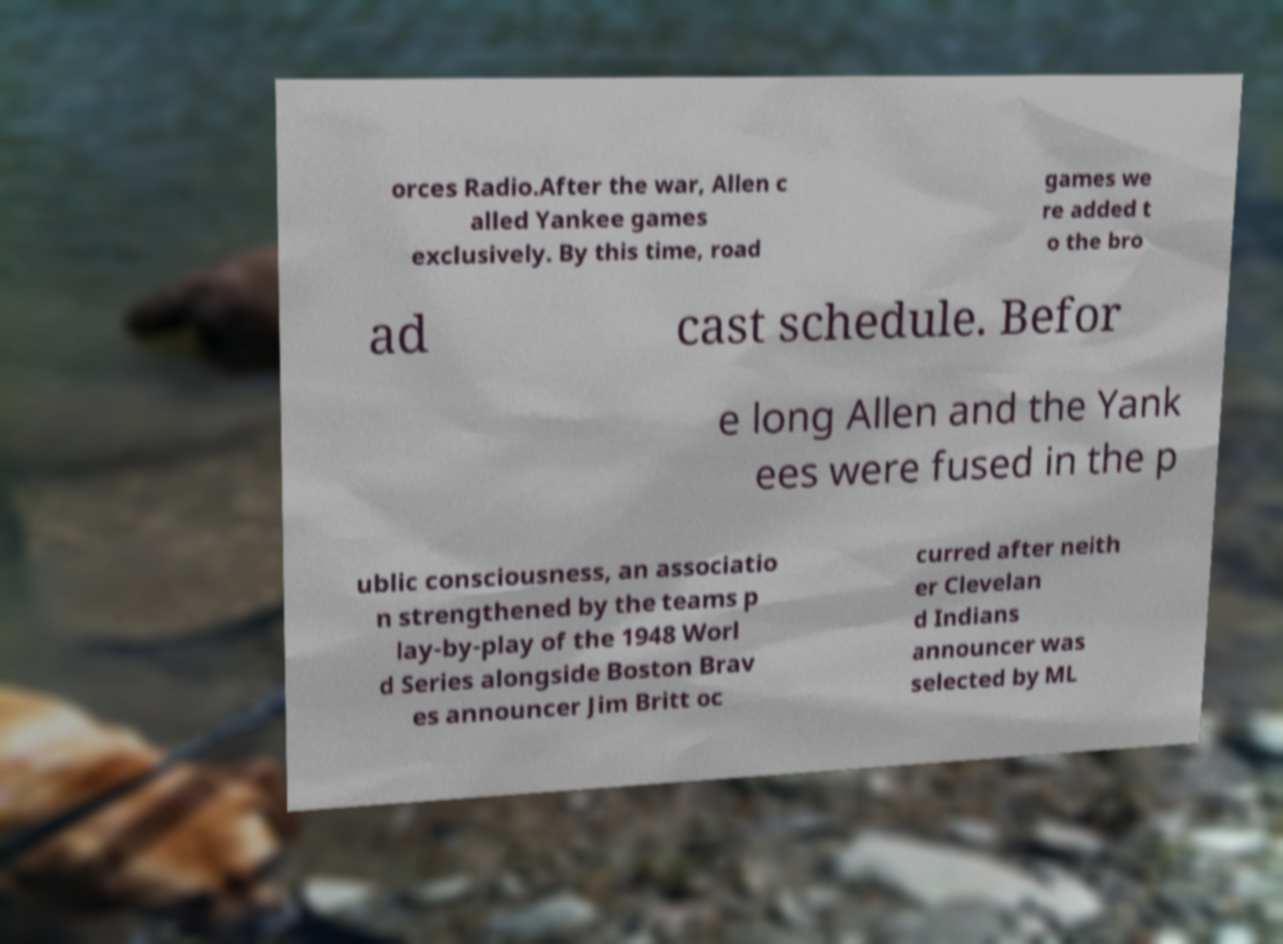Can you read and provide the text displayed in the image?This photo seems to have some interesting text. Can you extract and type it out for me? orces Radio.After the war, Allen c alled Yankee games exclusively. By this time, road games we re added t o the bro ad cast schedule. Befor e long Allen and the Yank ees were fused in the p ublic consciousness, an associatio n strengthened by the teams p lay-by-play of the 1948 Worl d Series alongside Boston Brav es announcer Jim Britt oc curred after neith er Clevelan d Indians announcer was selected by ML 